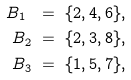Convert formula to latex. <formula><loc_0><loc_0><loc_500><loc_500>B _ { 1 } \ & = \ \{ 2 , 4 , 6 \} , \\ B _ { 2 } \ & = \ \{ 2 , 3 , 8 \} , \\ B _ { 3 } \ & = \ \{ 1 , 5 , 7 \} ,</formula> 